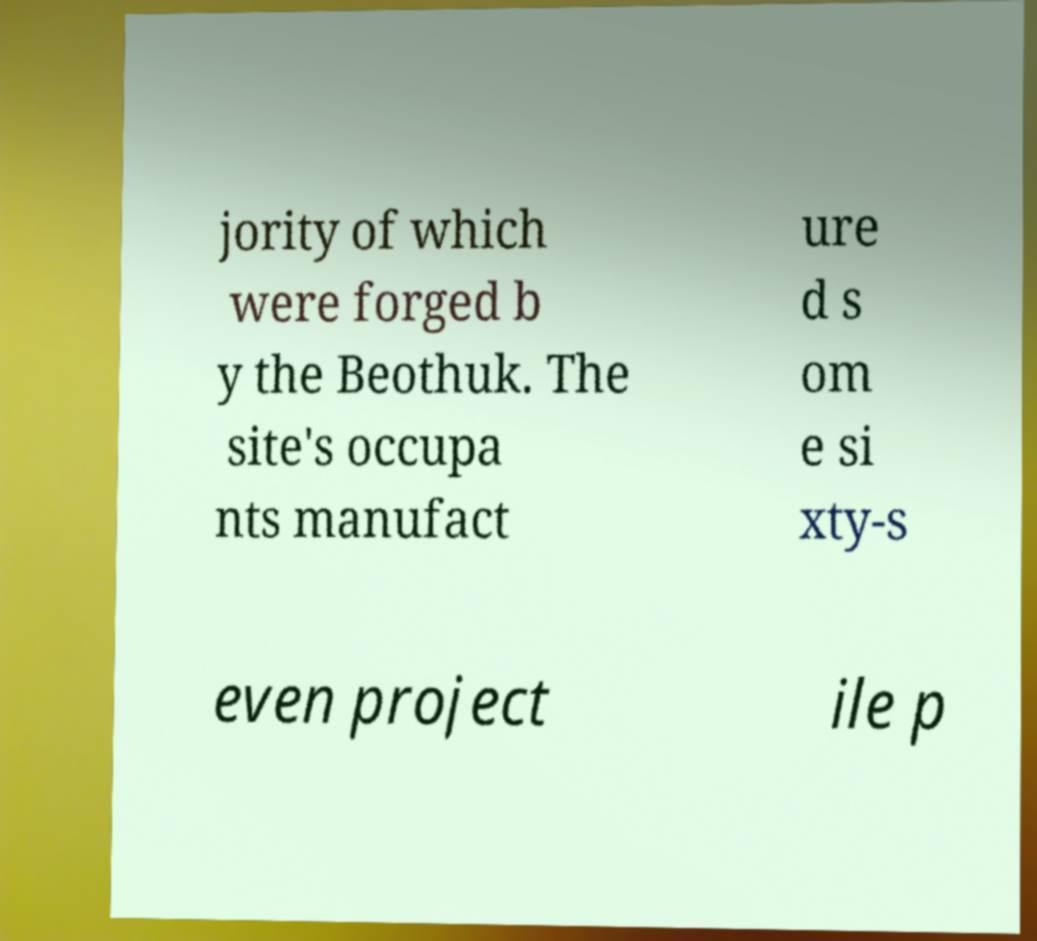For documentation purposes, I need the text within this image transcribed. Could you provide that? jority of which were forged b y the Beothuk. The site's occupa nts manufact ure d s om e si xty-s even project ile p 